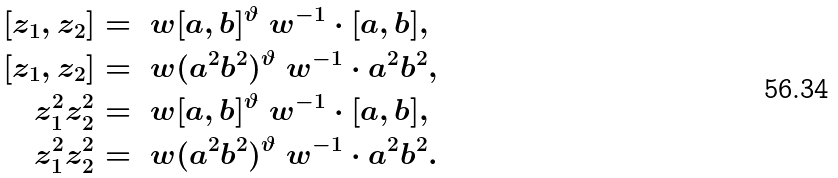Convert formula to latex. <formula><loc_0><loc_0><loc_500><loc_500>[ z _ { 1 } , z _ { 2 } ] & = \ w [ a , b ] ^ { \vartheta } \ w ^ { - 1 } \cdot [ a , b ] , \\ [ z _ { 1 } , z _ { 2 } ] & = \ w ( a ^ { 2 } b ^ { 2 } ) ^ { \vartheta } \ w ^ { - 1 } \cdot a ^ { 2 } b ^ { 2 } , \\ z _ { 1 } ^ { 2 } z _ { 2 } ^ { 2 } & = \ w [ a , b ] ^ { \vartheta } \ w ^ { - 1 } \cdot [ a , b ] , \\ z _ { 1 } ^ { 2 } z _ { 2 } ^ { 2 } & = \ w ( a ^ { 2 } b ^ { 2 } ) ^ { \vartheta } \ w ^ { - 1 } \cdot a ^ { 2 } b ^ { 2 } .</formula> 